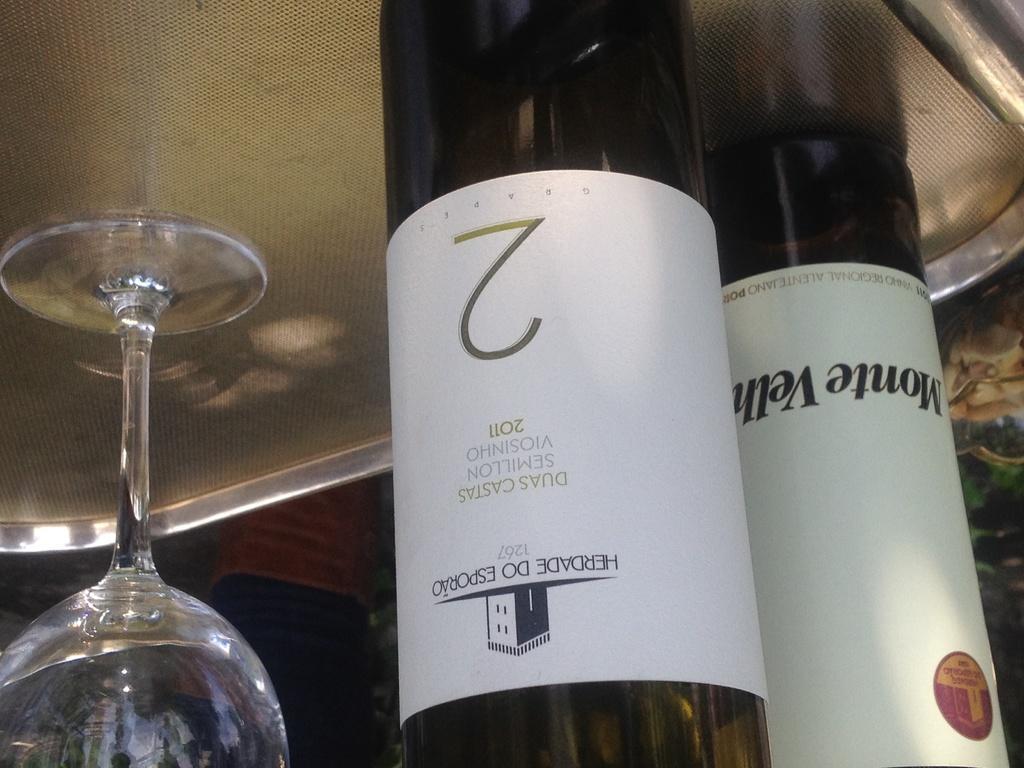How would you summarize this image in a sentence or two? In this image there is a table and we can see a tray, wine glass and wine bottles placed on the table. 